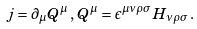<formula> <loc_0><loc_0><loc_500><loc_500>j = \partial _ { \mu } Q ^ { \mu } \, , \, Q ^ { \mu } = \epsilon ^ { \mu \nu \rho \sigma } H _ { \nu \rho \sigma } \, .</formula> 